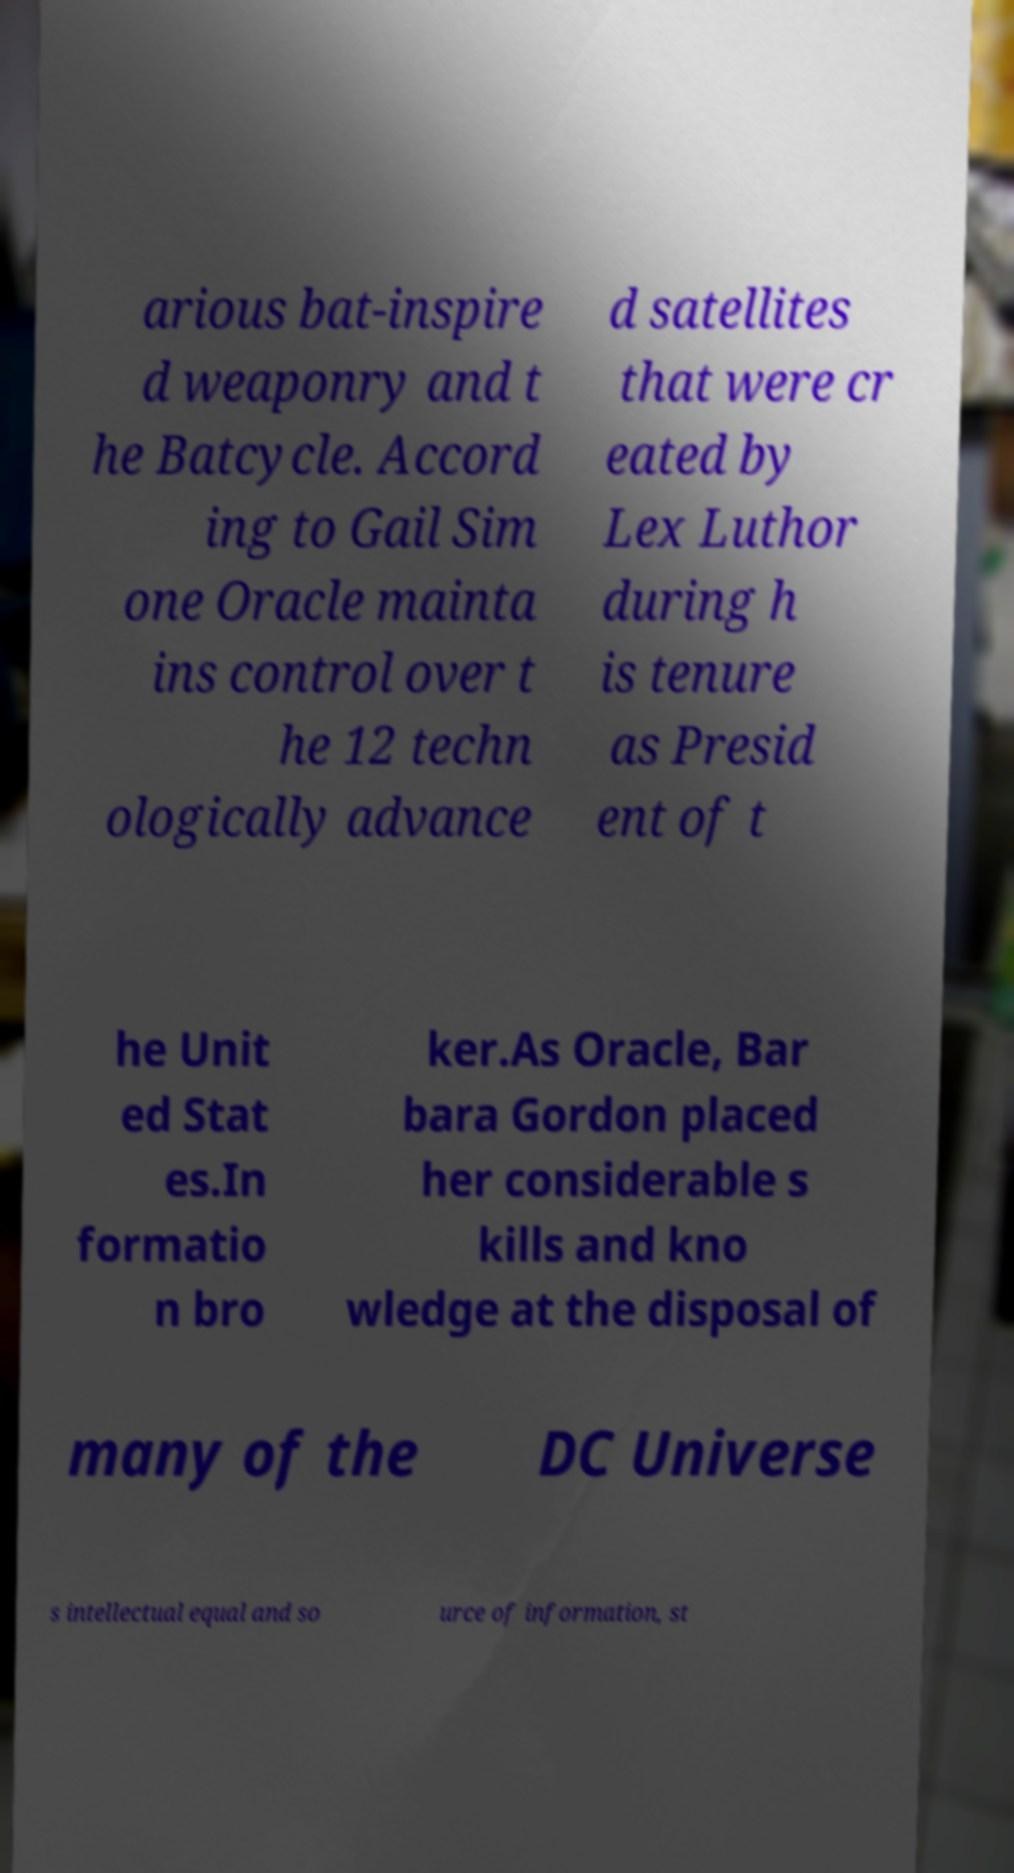Could you assist in decoding the text presented in this image and type it out clearly? arious bat-inspire d weaponry and t he Batcycle. Accord ing to Gail Sim one Oracle mainta ins control over t he 12 techn ologically advance d satellites that were cr eated by Lex Luthor during h is tenure as Presid ent of t he Unit ed Stat es.In formatio n bro ker.As Oracle, Bar bara Gordon placed her considerable s kills and kno wledge at the disposal of many of the DC Universe s intellectual equal and so urce of information, st 